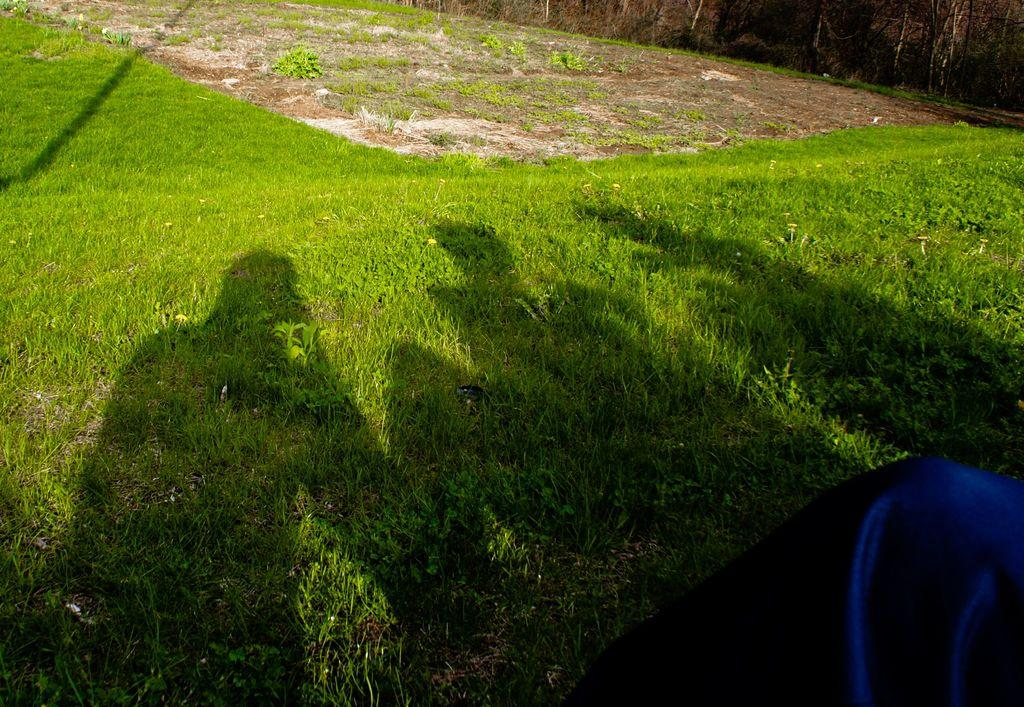What can be seen in the image that indicates the presence of people? There are shadows of people in the image. What type of vegetation is visible in the image? There are plants and trees in the image. What is the ground covered with in the image? There is grass visible in the image. What type of glass is being distributed in the image? There is no glass or distribution of any kind present in the image. What type of plantation can be seen in the image? There is no plantation present in the image; it features shadows of people, plants, trees, and grass. 